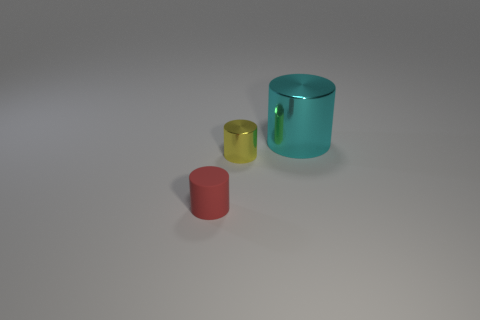What is the size of the metallic object that is behind the small yellow metallic thing?
Your answer should be very brief. Large. There is a small thing behind the small red cylinder; is it the same shape as the tiny red thing?
Your response must be concise. Yes. What is the size of the cyan metal cylinder?
Offer a terse response. Large. The other tiny object that is the same shape as the tiny red thing is what color?
Keep it short and to the point. Yellow. Does the cylinder in front of the tiny shiny object have the same size as the metallic object left of the cyan shiny cylinder?
Your response must be concise. Yes. Is the number of yellow shiny objects that are behind the yellow cylinder the same as the number of cylinders that are on the right side of the small red rubber object?
Your response must be concise. No. There is a matte cylinder; is its size the same as the thing that is behind the small yellow shiny cylinder?
Your answer should be very brief. No. There is a tiny thing behind the red matte object; is there a small thing to the left of it?
Offer a terse response. Yes. Are there any other big objects that have the same shape as the red object?
Ensure brevity in your answer.  Yes. There is a thing on the right side of the small cylinder that is on the right side of the tiny red cylinder; how many shiny objects are in front of it?
Make the answer very short. 1. 